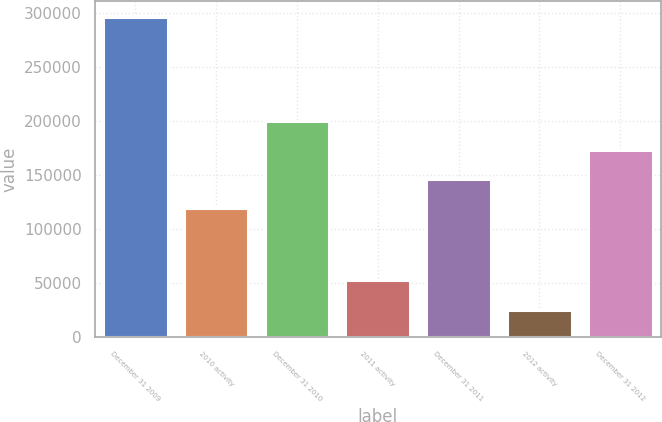Convert chart to OTSL. <chart><loc_0><loc_0><loc_500><loc_500><bar_chart><fcel>December 31 2009<fcel>2010 activity<fcel>December 31 2010<fcel>2011 activity<fcel>December 31 2011<fcel>2012 activity<fcel>December 31 2012<nl><fcel>296182<fcel>119200<fcel>200349<fcel>52734.7<fcel>146250<fcel>25685<fcel>173299<nl></chart> 